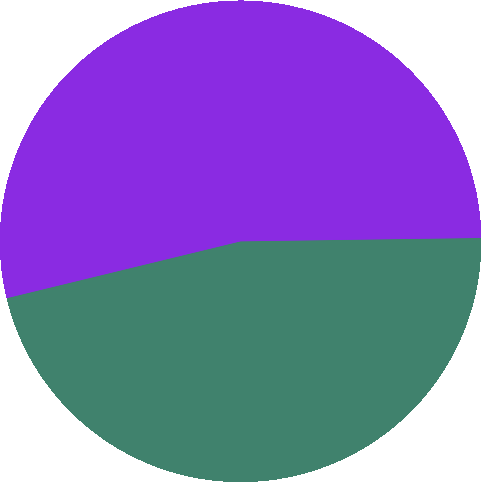Convert chart. <chart><loc_0><loc_0><loc_500><loc_500><pie_chart><fcel>2005 Plan<fcel>Director Plan<nl><fcel>46.43%<fcel>53.57%<nl></chart> 